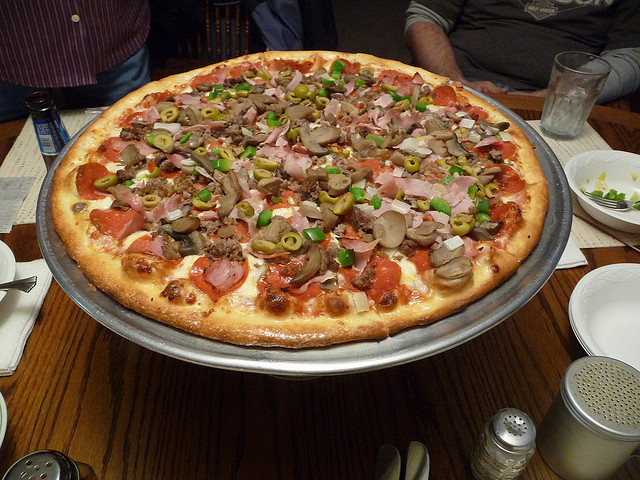What kind of occasion might this pizza be suitable for? This large pizza, with its variety of toppings, would be perfect for a social gathering such as a family dinner, a party with friends, or any casual event where food is shared in a group. 